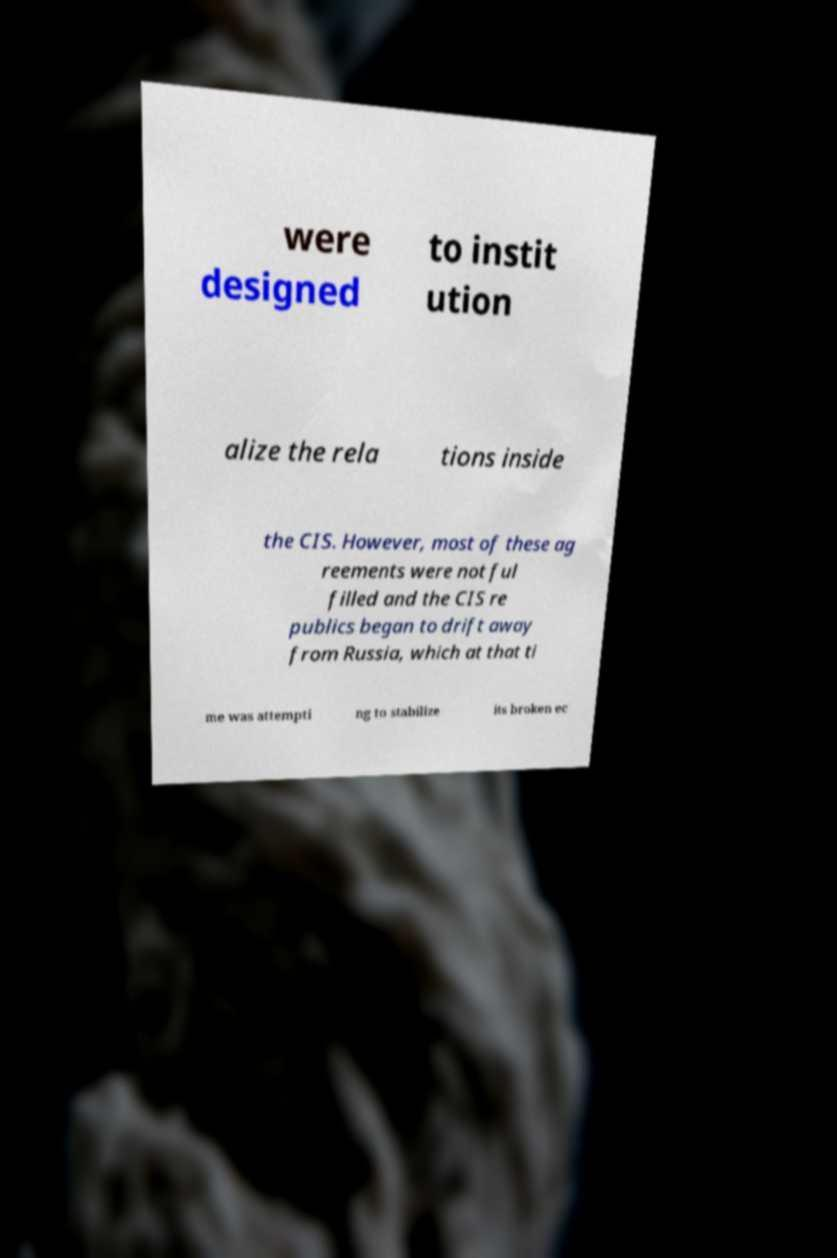Could you extract and type out the text from this image? were designed to instit ution alize the rela tions inside the CIS. However, most of these ag reements were not ful filled and the CIS re publics began to drift away from Russia, which at that ti me was attempti ng to stabilize its broken ec 